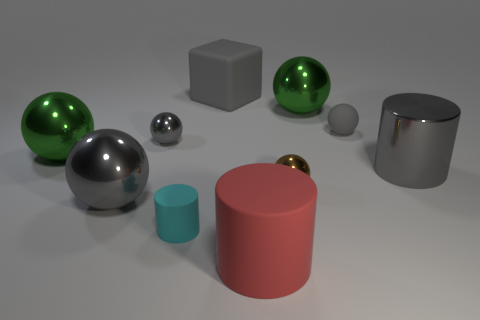There is a large metallic ball that is in front of the green ball that is to the left of the large gray matte object; what is its color?
Your answer should be compact. Gray. There is a tiny rubber object that is the same shape as the tiny brown metallic object; what color is it?
Your answer should be compact. Gray. Is there any other thing that has the same material as the block?
Offer a terse response. Yes. The other metal thing that is the same shape as the tiny cyan thing is what size?
Provide a succinct answer. Large. There is a big gray thing in front of the gray cylinder; what is it made of?
Make the answer very short. Metal. Are there fewer things on the left side of the matte ball than tiny gray balls?
Provide a short and direct response. No. What is the shape of the tiny gray thing on the left side of the large gray rubber block that is behind the tiny brown shiny object?
Ensure brevity in your answer.  Sphere. The big metal cylinder has what color?
Provide a succinct answer. Gray. What number of other objects are the same size as the cube?
Offer a very short reply. 5. What is the material of the tiny thing that is on the left side of the large red cylinder and behind the small cyan rubber thing?
Make the answer very short. Metal. 